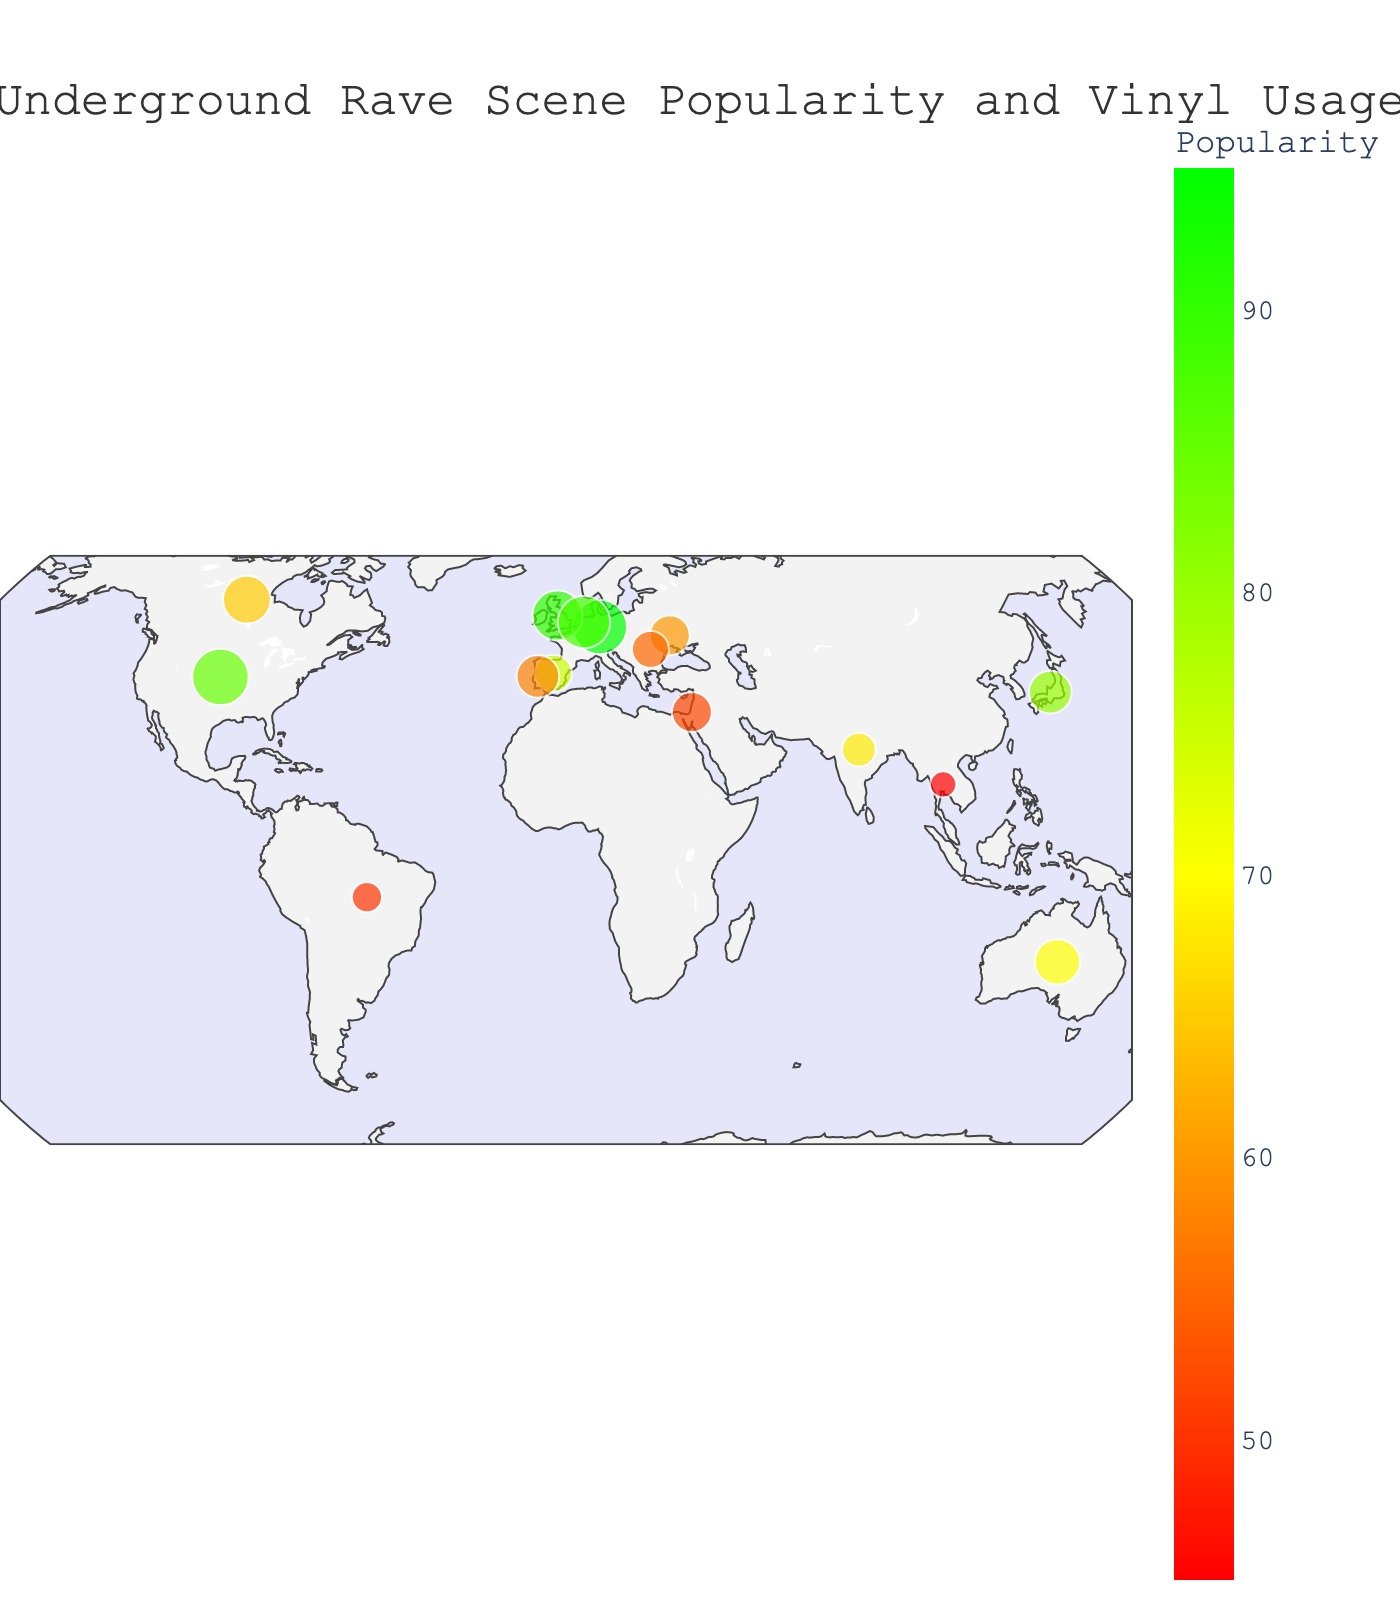What is the title of the map? The title of the map is usually displayed at the top of the figure. In this case, it is written clearly in the figure's layout section.
Answer: Underground Rave Scene Popularity and Vinyl Usage Which city has the highest rave popularity? To find the city with the highest rave popularity, look for the city with the highest value in the "UndergroundRavePopularity" field. According to the data, the highest value is 95.
Answer: Berlin Which city has the lowest vinyl usage percentage? To find the city with the lowest vinyl usage percentage, look for the smallest circle on the map as circles represent vinyl usage. The smallest circle corresponds to the value 15.
Answer: Bangkok What is the legal status of underground raves in Detroit, USA? Hover over the city of Detroit on the map, and it will display its details, including the legal status. According to the figure, the legal status of Detroit is shown.
Answer: Semi-legal How many cities have a ‘Legal’ status for underground raves? Count the number of cities that are listed as having a 'Legal' status as shown on the map's hover data. According to the data, there are several such cities.
Answer: 6 What is the average popularity of underground raves in cities with a "Legal" status? First, identify the cities with "Legal" status: Berlin, Amsterdam, Ibiza, Montreal, Lisbon. Then, sum up their popularity values and divide by the number of these cities. The calculations are (95+88+75+65+58)/5.
Answer: 76.2 Which city has the highest vinyl usage percentage and what is its popularity score? To find this, look for the city with the largest circle on the map. According to the data, the highest vinyl usage percentage is 70.
Answer: Detroit, 85 How does Tokyo's rave popularity compare to Lisbon's? Find the value for both Tokyo and Lisbon by checking their positions on the map and their corresponding colors/sizes. Tokyo's popularity value is 80 while Lisbon's is 58.
Answer: Tokyo's rave scene is more popular than Lisbon's Which city has both a high rave popularity and a higher-than-average vinyl usage? First, determine the average vinyl usage percentage from the data. Then, identify a city with above-average vinyl usage and high popularity. Calculating the average vinyl usage: (65+55+60+70+40+30+45+25+50+35+40+30+35+20+15)/15 = 41.67. Look for a city with a popularity score above this and high vinyl usage.
Answer: Berlin In which region do you see a cluster of highly popular rave scenes? Observe the geographic plot to identify any regions with multiple cities that have high popularity. These regions are usually highlighted by the abundance of larger and brighter circles. According to the data and visual information, Europe has several highly popular scenes.
Answer: Europe 